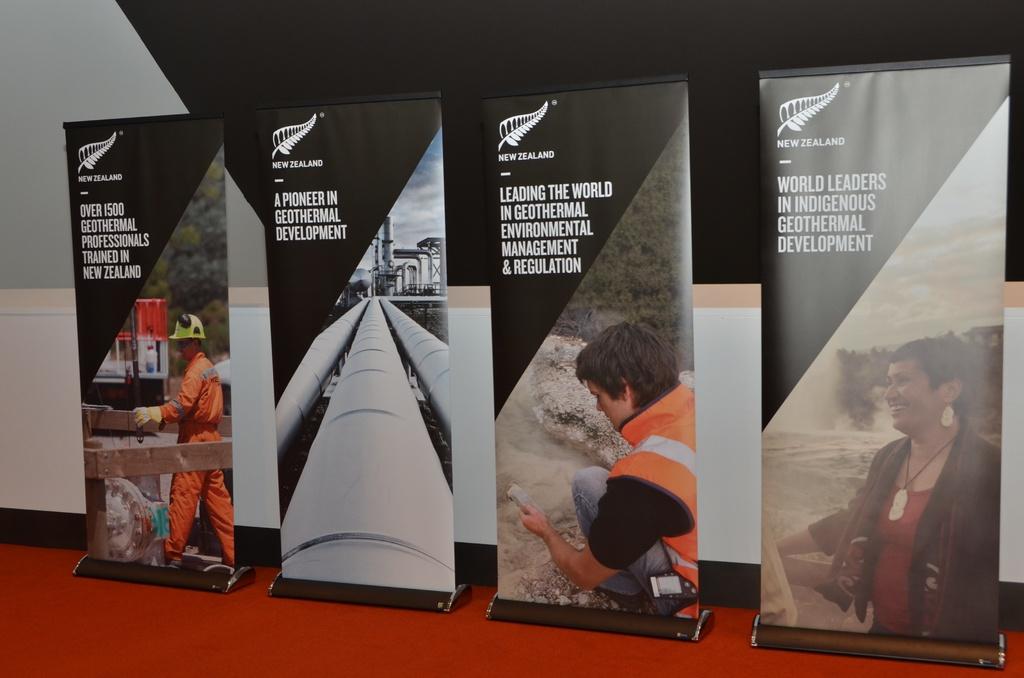What country is a pioneer in geothermal development?
Give a very brief answer. New zealand. What is the name of the country at the top of the brochures?
Ensure brevity in your answer.  New zealand. 